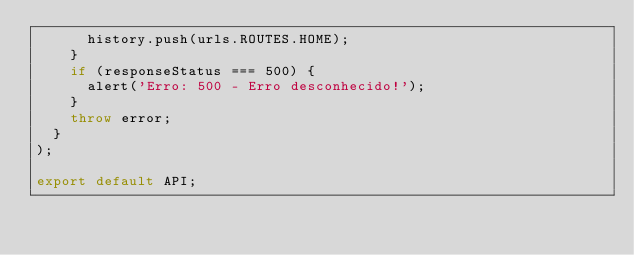Convert code to text. <code><loc_0><loc_0><loc_500><loc_500><_JavaScript_>      history.push(urls.ROUTES.HOME);
    }
    if (responseStatus === 500) {
      alert('Erro: 500 - Erro desconhecido!');
    }
    throw error;
  }
);

export default API;
</code> 